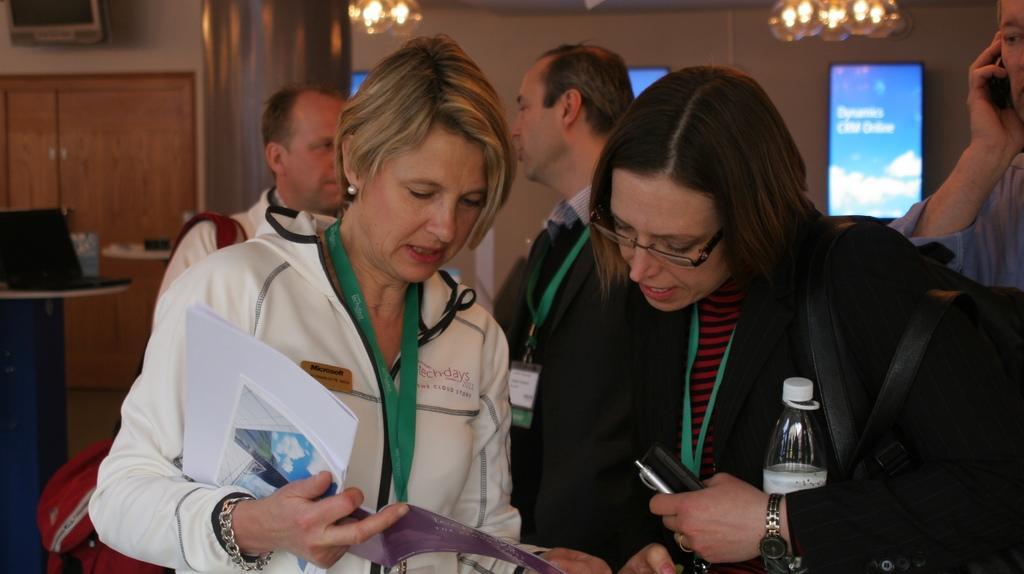Please provide a concise description of this image. In this image I can see five persons are standing on the floor and are holding some objects in their hand. In the background I can see screens, chandeliers, wall, door, table, laptop and some objects. This image is taken may be in a hall. 